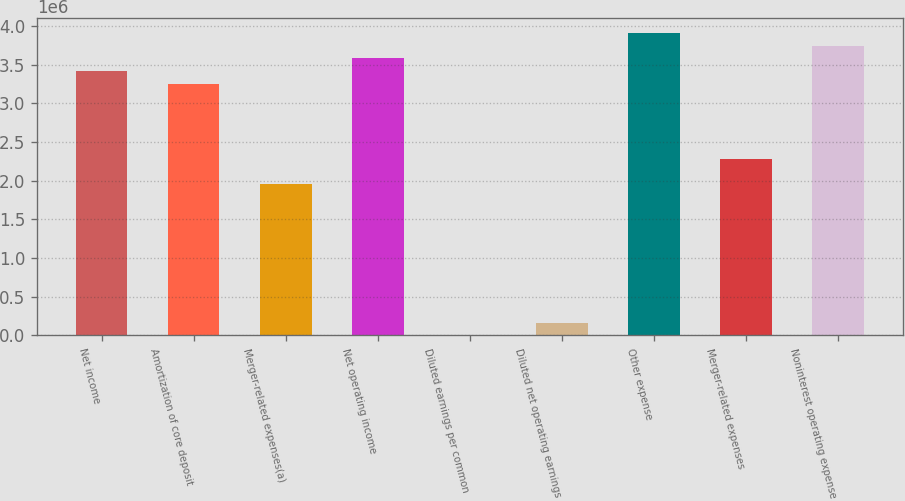Convert chart to OTSL. <chart><loc_0><loc_0><loc_500><loc_500><bar_chart><fcel>Net income<fcel>Amortization of core deposit<fcel>Merger-related expenses(a)<fcel>Net operating income<fcel>Diluted earnings per common<fcel>Diluted net operating earnings<fcel>Other expense<fcel>Merger-related expenses<fcel>Noninterest operating expense<nl><fcel>3.41814e+06<fcel>3.25537e+06<fcel>1.95323e+06<fcel>3.58091e+06<fcel>5.95<fcel>162774<fcel>3.90645e+06<fcel>2.27876e+06<fcel>3.74368e+06<nl></chart> 